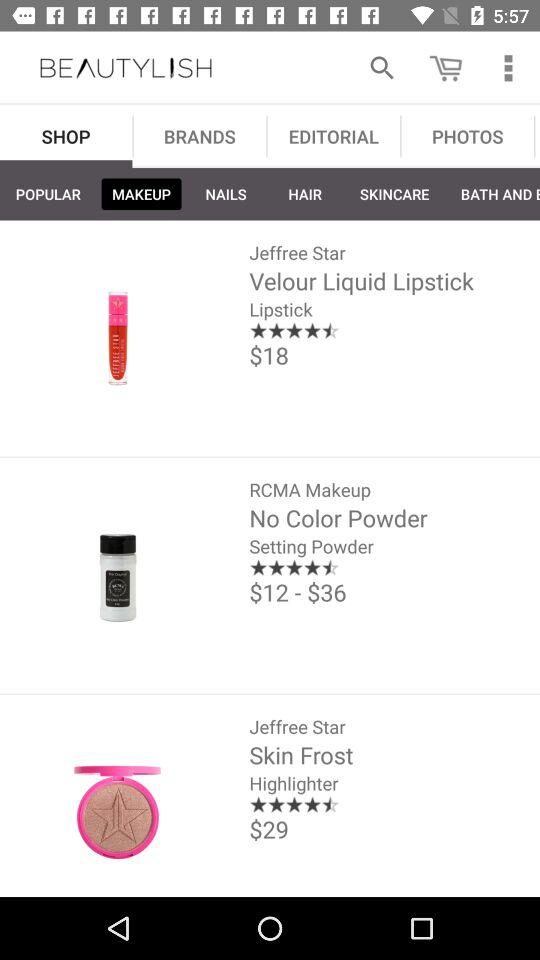What is the rating of lipstick? The rating is 4.5 stars. 